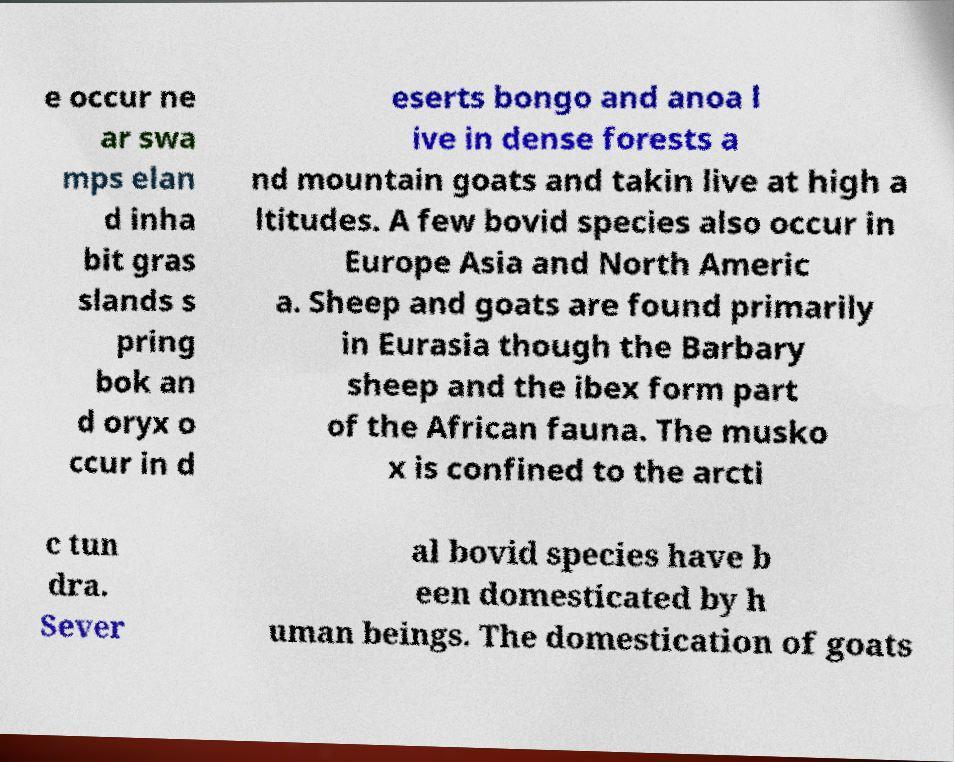Could you assist in decoding the text presented in this image and type it out clearly? e occur ne ar swa mps elan d inha bit gras slands s pring bok an d oryx o ccur in d eserts bongo and anoa l ive in dense forests a nd mountain goats and takin live at high a ltitudes. A few bovid species also occur in Europe Asia and North Americ a. Sheep and goats are found primarily in Eurasia though the Barbary sheep and the ibex form part of the African fauna. The musko x is confined to the arcti c tun dra. Sever al bovid species have b een domesticated by h uman beings. The domestication of goats 